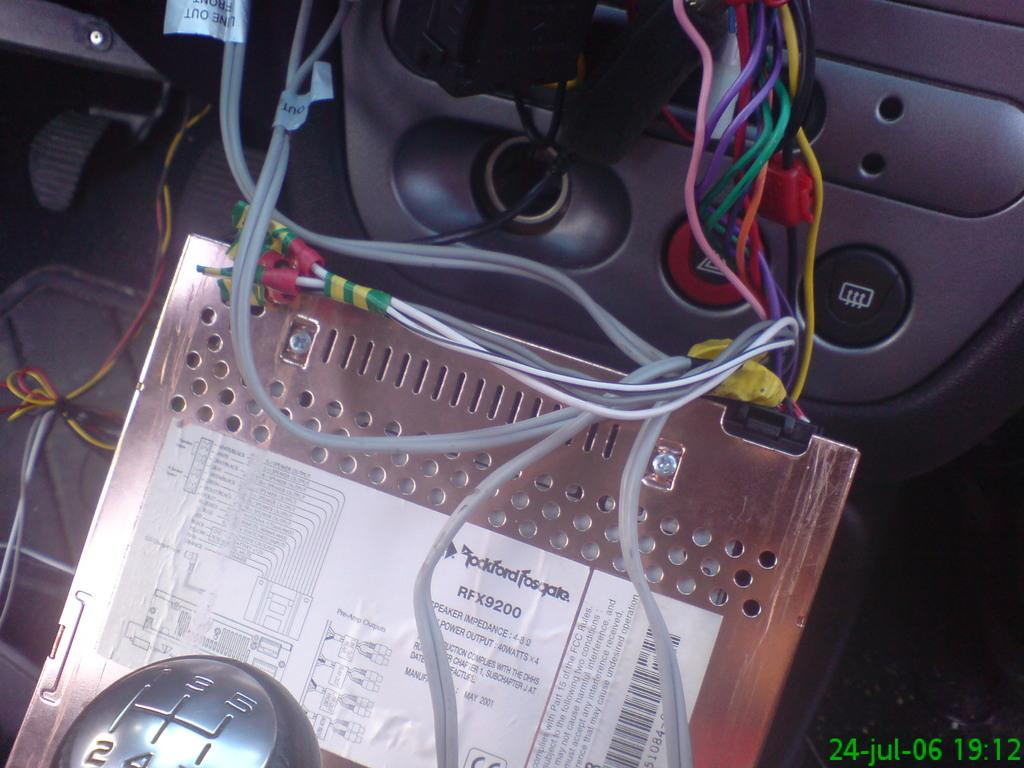What type of space is depicted in the image? The image shows the interior of a vehicle. What can be seen inside the vehicle? There are wires visible in the vehicle, as well as a gear rod. Can you describe a specific object with a label in the vehicle? There is a metal object with a white-colored sticker in the vehicle. What type of bed can be seen in the image? There is no bed present in the image; it shows the interior of a vehicle. Can you point out a map in the image? There is no map visible in the image. 